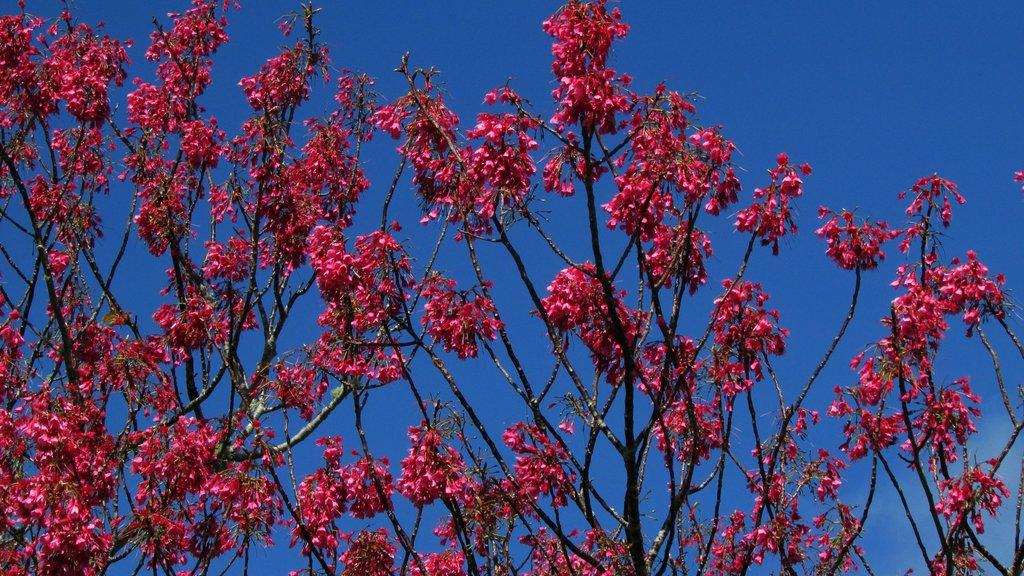What type of flora can be seen in the image? There are flowers in the image. What color are the flowers? The flowers are pink in color. What can be seen in the background of the image? The sky is visible in the background of the image. What is the color of the sky? The sky is blue in color. What type of land can be seen in the image? There is no land visible in the image; it only features flowers and the sky. What is the reaction of the flowers to the wind in the image? There is no wind or reaction to wind present in the image; the flowers are stationary. 